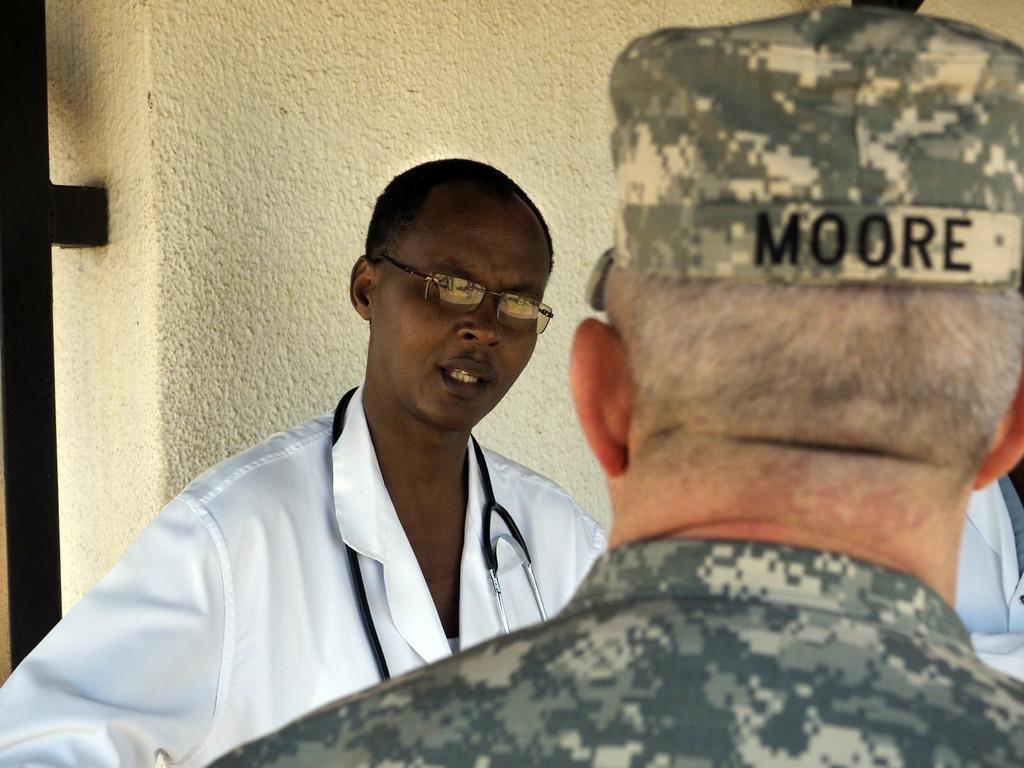How would you summarize this image in a sentence or two? In the image few people are standing. Behind them there is wall. 